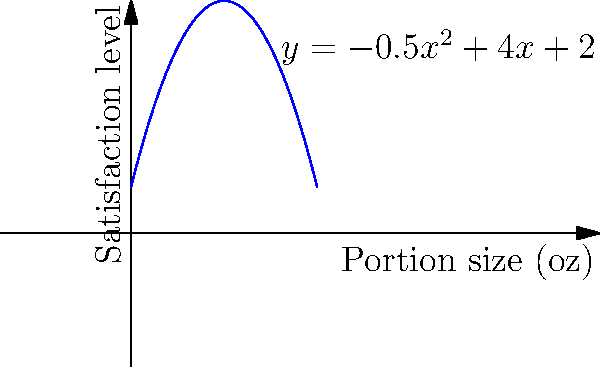As a nutritionist, you're developing a model to optimize snack portion sizes for screen time breaks. The polynomial function $f(x) = -0.5x^2 + 4x + 2$ represents the relationship between portion size (x) in ounces and satisfaction level (y). What is the optimal portion size to maximize satisfaction, and what is the corresponding maximum satisfaction level? To find the optimal portion size and maximum satisfaction level, we need to follow these steps:

1) The function $f(x) = -0.5x^2 + 4x + 2$ is a quadratic function, and its graph is a parabola that opens downward (because the coefficient of $x^2$ is negative).

2) The vertex of this parabola represents the maximum point, which gives us the optimal portion size and maximum satisfaction level.

3) To find the x-coordinate of the vertex (optimal portion size), we use the formula $x = -\frac{b}{2a}$, where $a$ and $b$ are the coefficients of $x^2$ and $x$ respectively:

   $x = -\frac{4}{2(-0.5)} = -\frac{4}{-1} = 4$ oz

4) To find the y-coordinate of the vertex (maximum satisfaction level), we substitute $x=4$ into the original function:

   $f(4) = -0.5(4)^2 + 4(4) + 2$
         $= -0.5(16) + 16 + 2$
         $= -8 + 16 + 2$
         $= 10$

Therefore, the optimal portion size is 4 oz, and the maximum satisfaction level is 10.
Answer: 4 oz; 10 